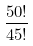<formula> <loc_0><loc_0><loc_500><loc_500>\frac { 5 0 ! } { 4 5 ! }</formula> 